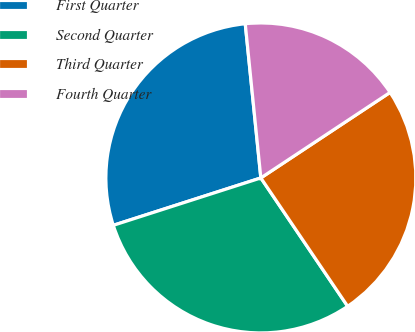Convert chart to OTSL. <chart><loc_0><loc_0><loc_500><loc_500><pie_chart><fcel>First Quarter<fcel>Second Quarter<fcel>Third Quarter<fcel>Fourth Quarter<nl><fcel>28.34%<fcel>29.52%<fcel>24.84%<fcel>17.3%<nl></chart> 